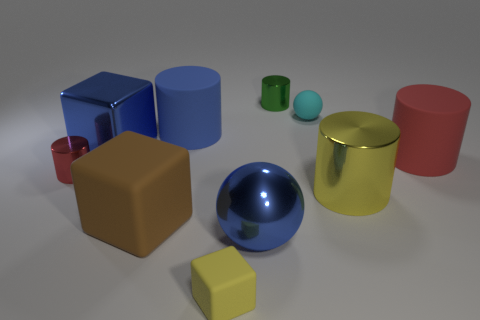Is the large sphere the same color as the metallic block? Based on the image, the large sphere and the metallic block indeed appear to share a similar blue hue. Although lighting and reflections can affect color perception, both objects exhibit shades that closely resemble one another. 